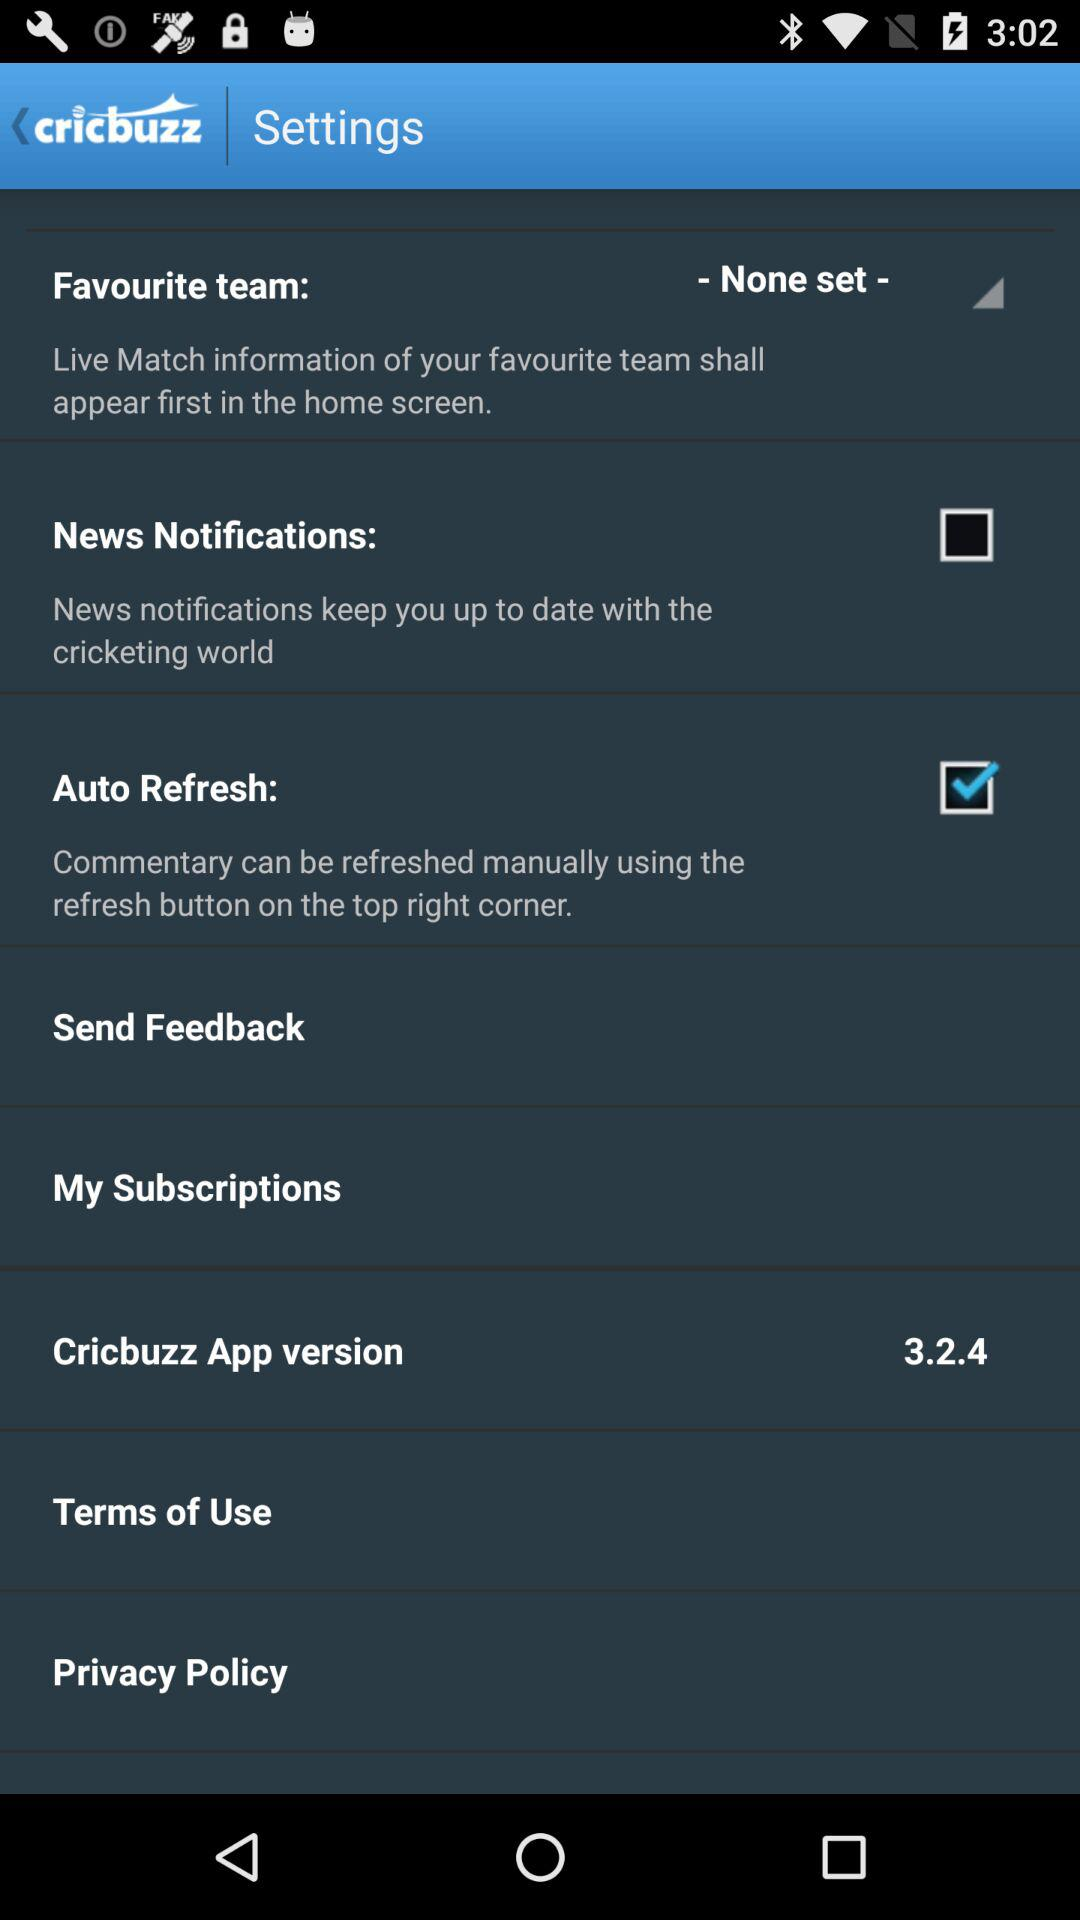What is the name of the application? The name of the application is "cricbuzz". 